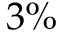<formula> <loc_0><loc_0><loc_500><loc_500>3 \%</formula> 